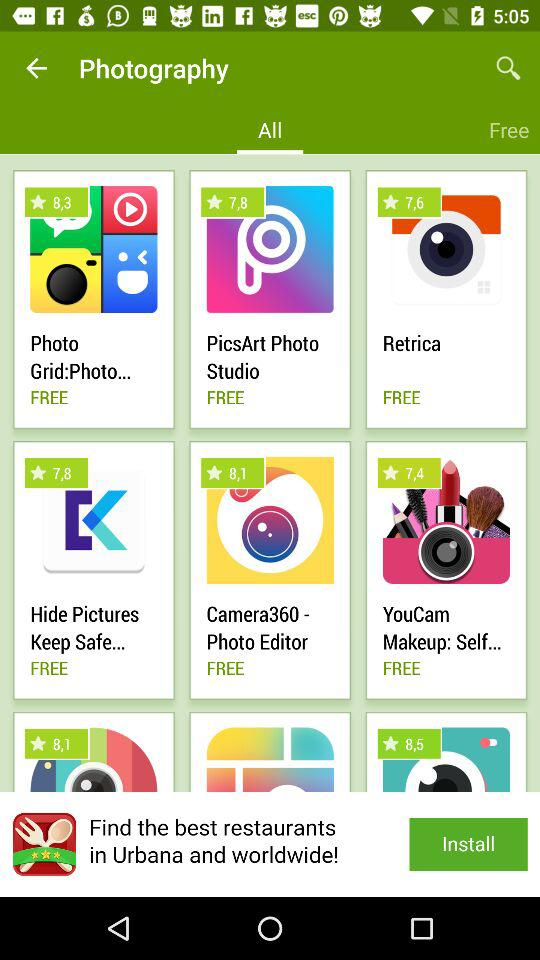What is the rating for the "Retrica" app? The rating is 7.6. 